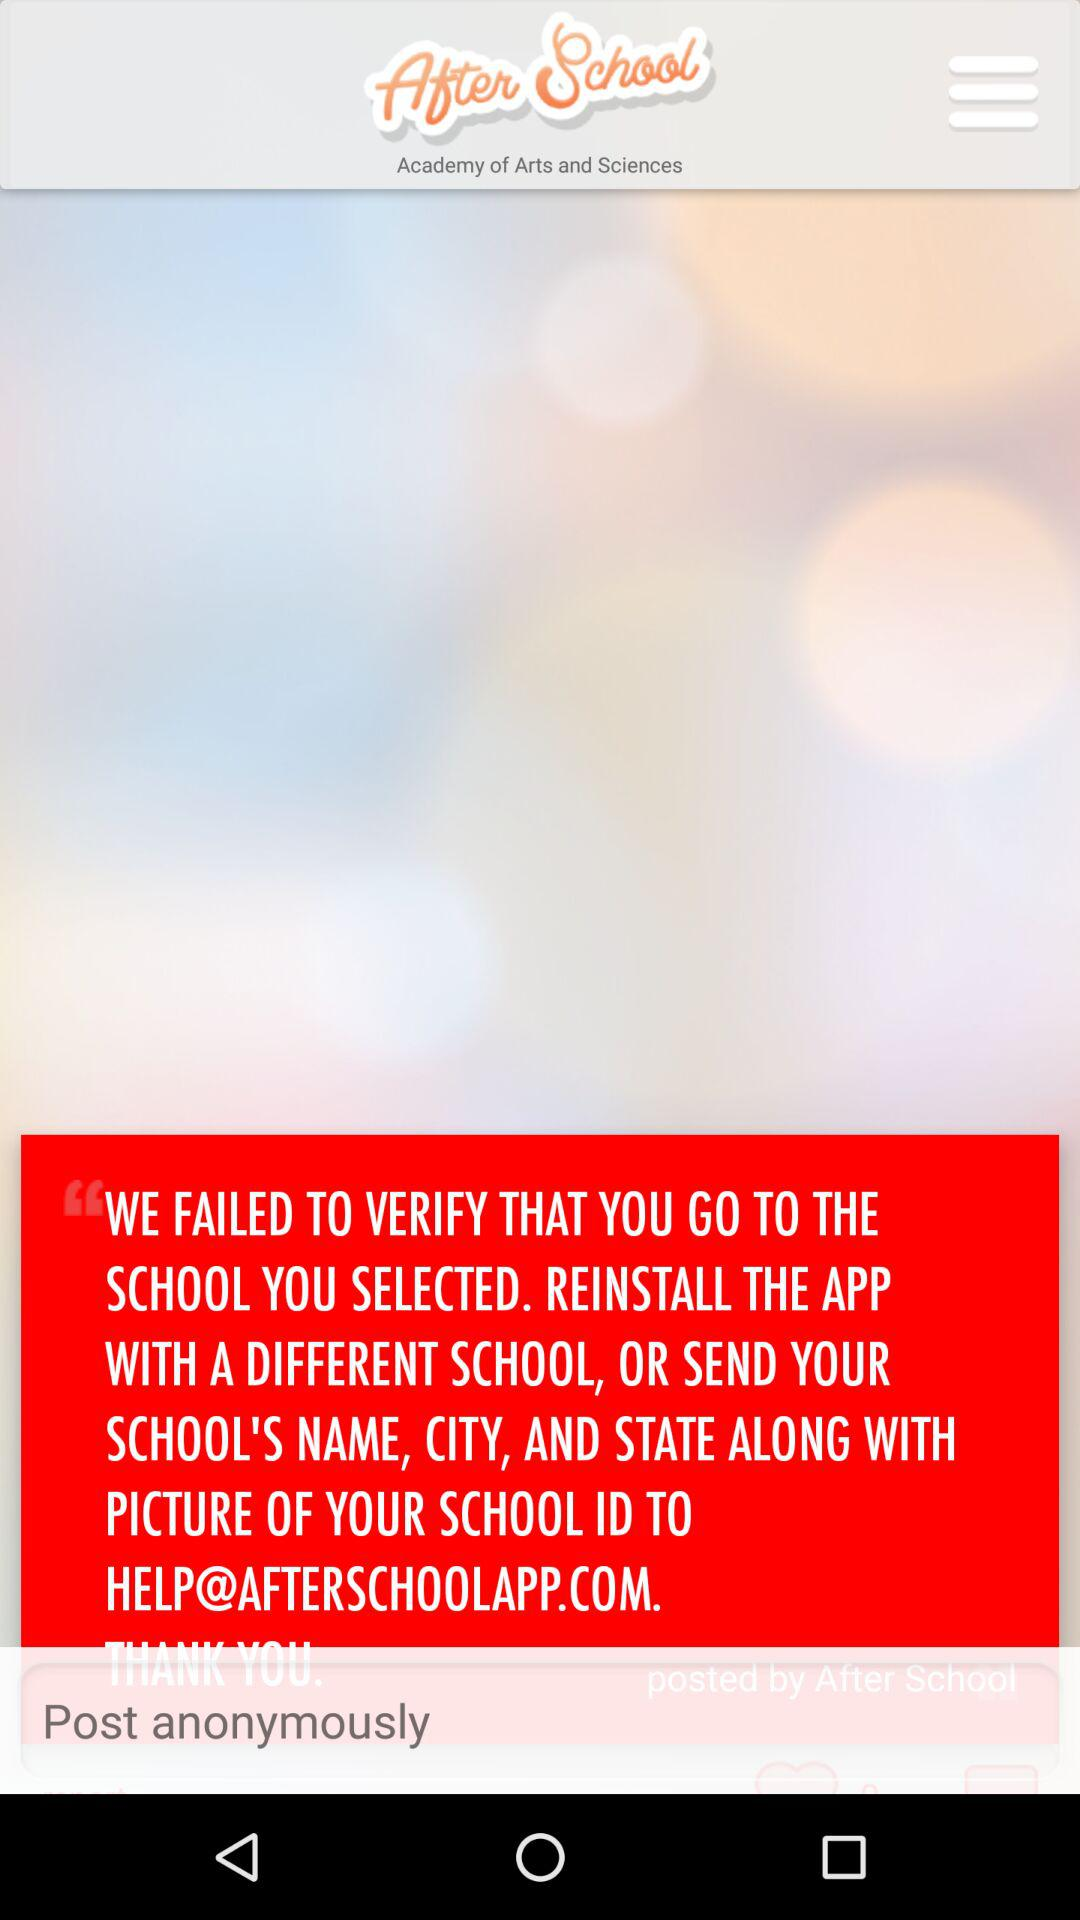Which stream of subjects are taught at the "After School" academy? The streams are arts and science. 